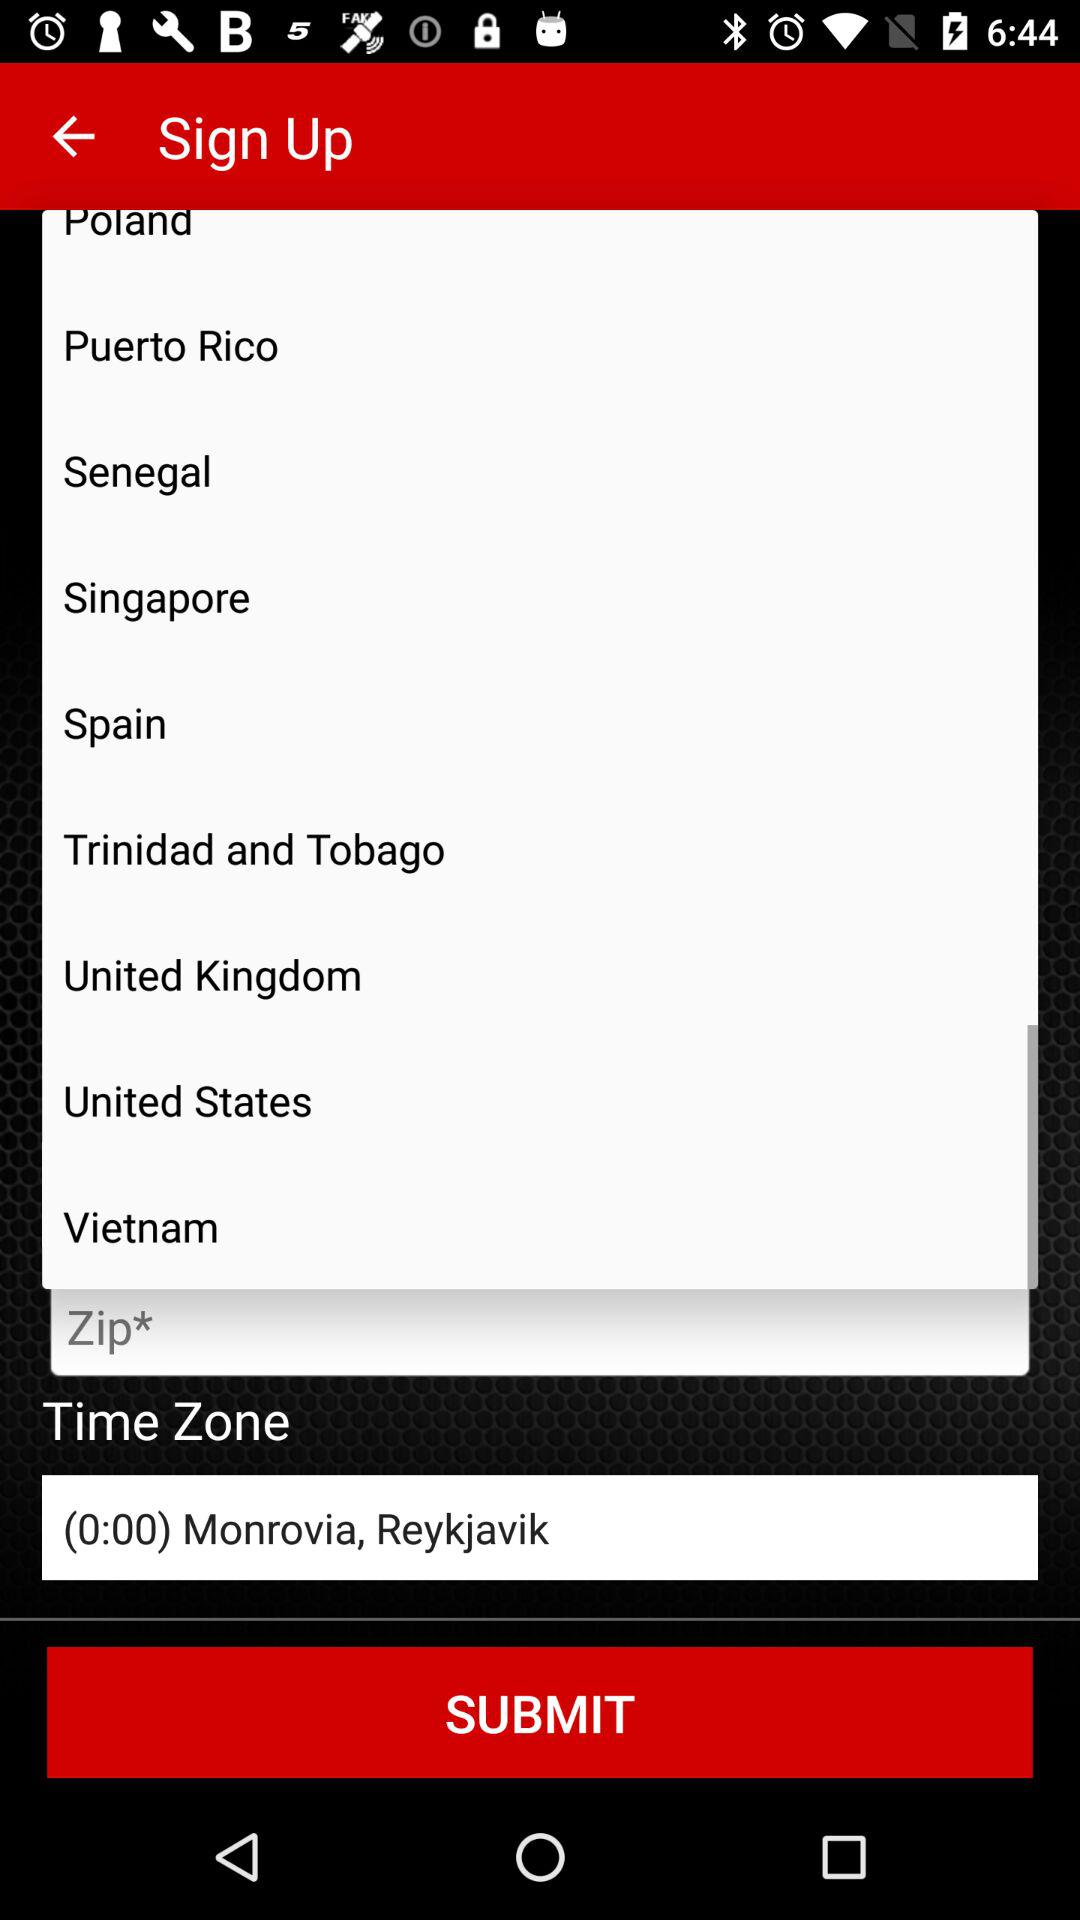What is the time zone? The time zone is (0:00) Monrovia, Reykjavik. 